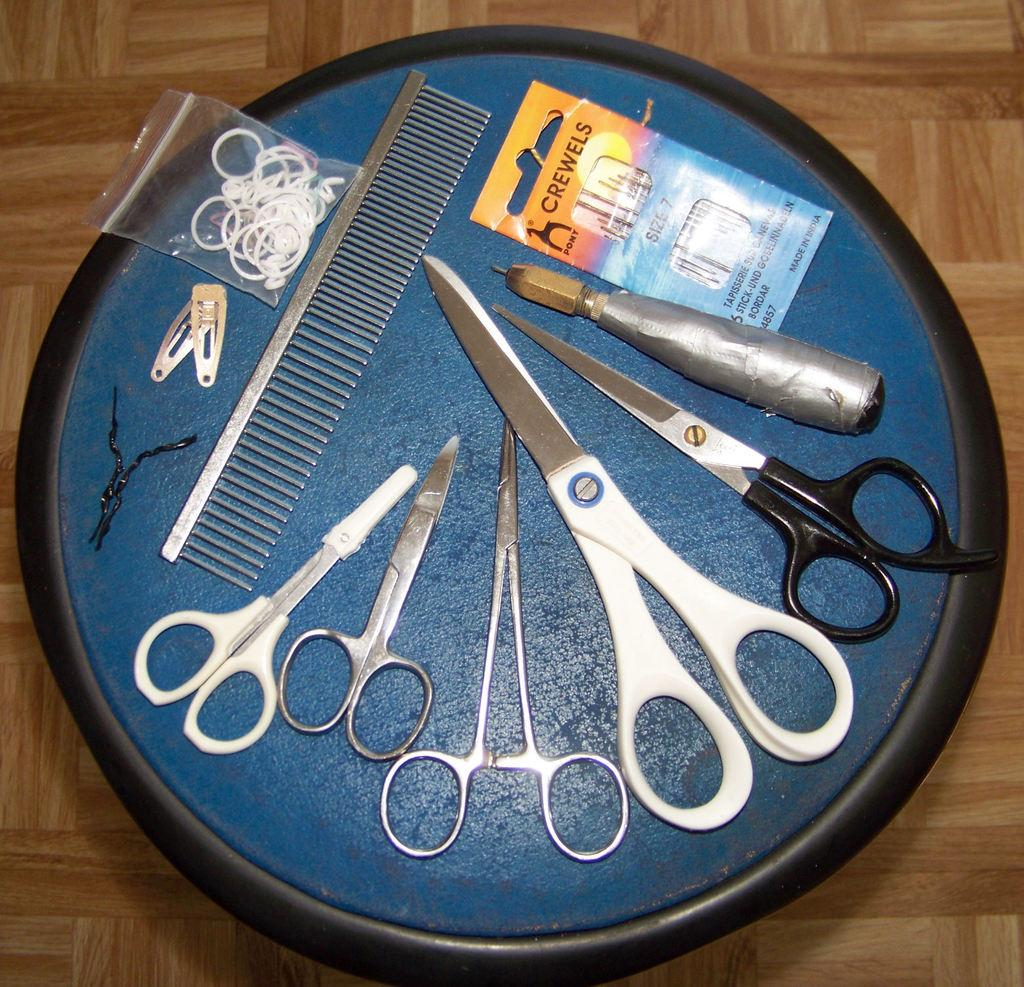What type of cutting tool is present in the image? There are scissors in the image. What other small objects can be seen in the image? There are pins in the image. What category do the scissors and pins belong to? They are both tools. How are the tools arranged in the image? The tools are placed on a tray. What is the surface at the bottom of the image made of? The surface at the bottom of the image is wooden. What color is the hair on the scissors in the image? There is no hair present on the scissors in the image. 